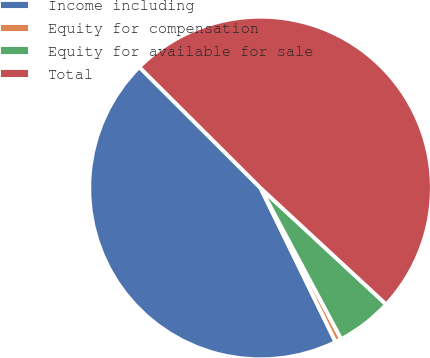Convert chart. <chart><loc_0><loc_0><loc_500><loc_500><pie_chart><fcel>Income including<fcel>Equity for compensation<fcel>Equity for available for sale<fcel>Total<nl><fcel>44.7%<fcel>0.59%<fcel>5.3%<fcel>49.41%<nl></chart> 